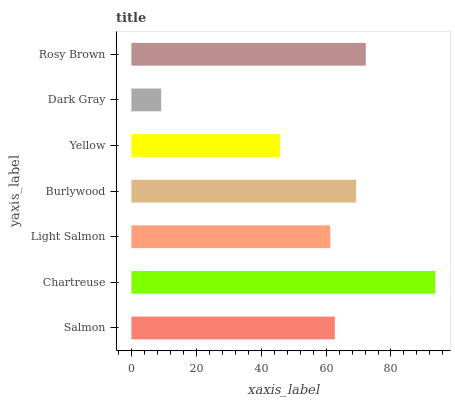Is Dark Gray the minimum?
Answer yes or no. Yes. Is Chartreuse the maximum?
Answer yes or no. Yes. Is Light Salmon the minimum?
Answer yes or no. No. Is Light Salmon the maximum?
Answer yes or no. No. Is Chartreuse greater than Light Salmon?
Answer yes or no. Yes. Is Light Salmon less than Chartreuse?
Answer yes or no. Yes. Is Light Salmon greater than Chartreuse?
Answer yes or no. No. Is Chartreuse less than Light Salmon?
Answer yes or no. No. Is Salmon the high median?
Answer yes or no. Yes. Is Salmon the low median?
Answer yes or no. Yes. Is Yellow the high median?
Answer yes or no. No. Is Dark Gray the low median?
Answer yes or no. No. 